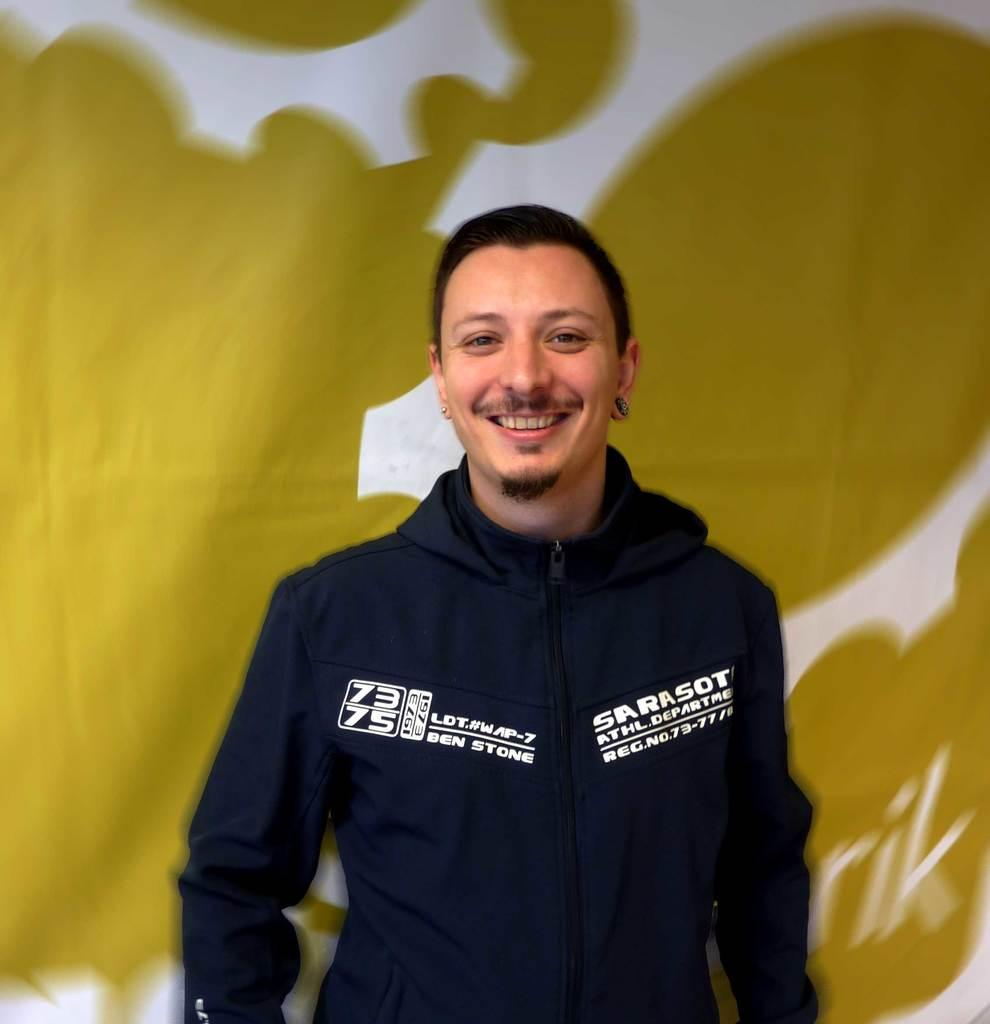Provide a one-sentence caption for the provided image. A man wearing a navy blue jacket with Ben Stone embroidered one side. 